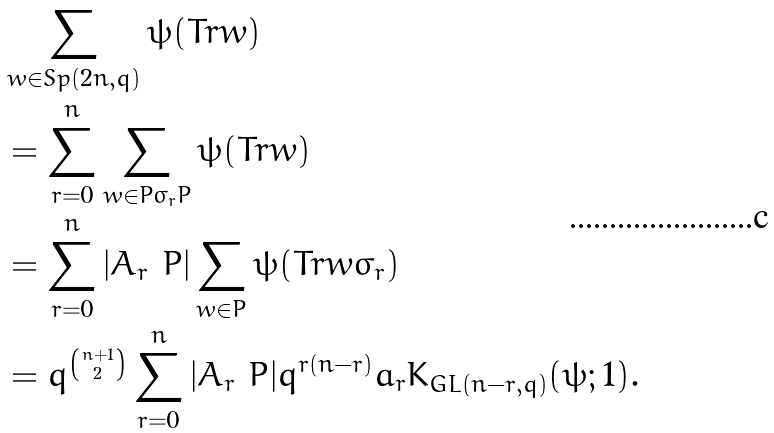Convert formula to latex. <formula><loc_0><loc_0><loc_500><loc_500>& \sum _ { w \in S p ( 2 n , q ) } \psi ( T r w ) \\ & = \sum _ { r = 0 } ^ { n } \sum _ { w \in P \sigma _ { r } P } \psi ( T r w ) \\ & = \sum _ { r = 0 } ^ { n } | A _ { r } \ P | \sum _ { w \in P } \psi ( T r w \sigma _ { r } ) \\ & = q ^ { \binom { n + 1 } { 2 } } \sum _ { r = 0 } ^ { n } | A _ { r } \ P | q ^ { r ( n - r ) } a _ { r } K _ { G L ( n - r , q ) } ( \psi ; 1 ) .</formula> 